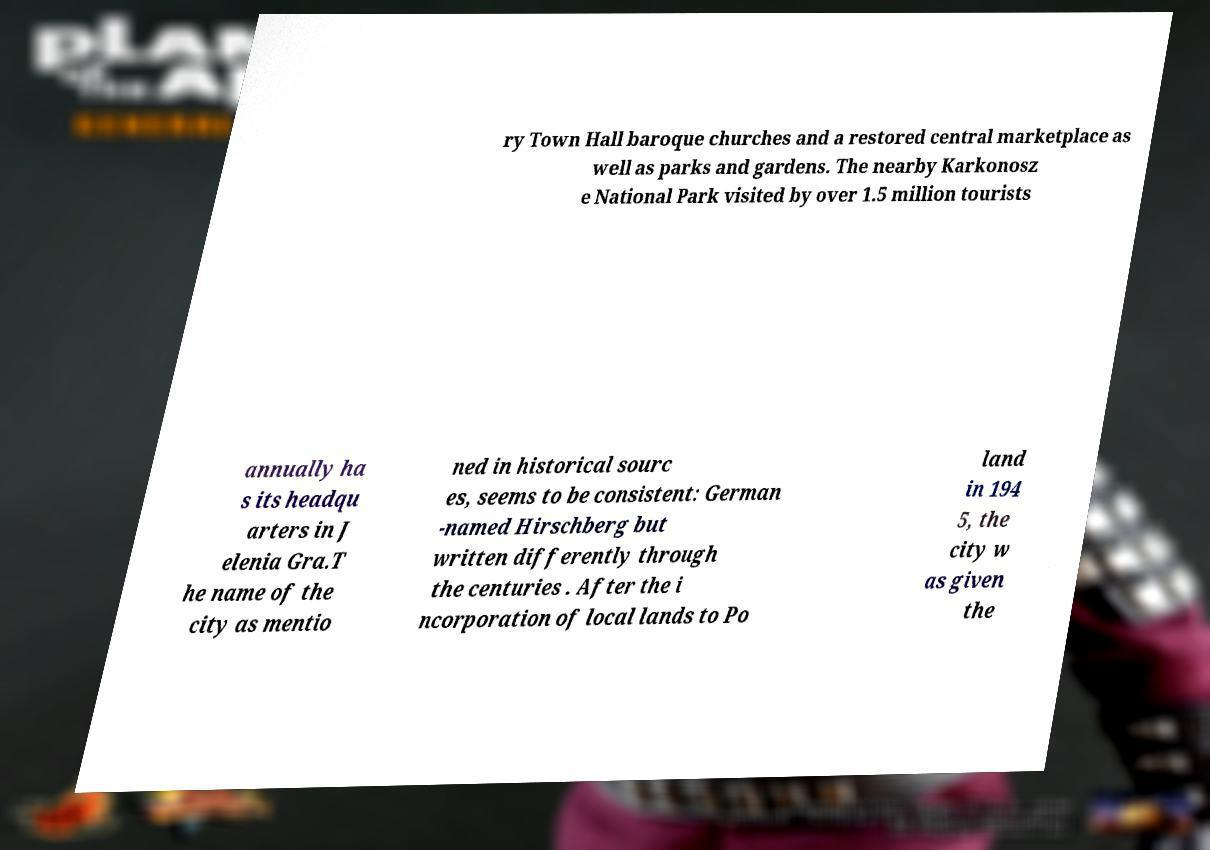There's text embedded in this image that I need extracted. Can you transcribe it verbatim? ry Town Hall baroque churches and a restored central marketplace as well as parks and gardens. The nearby Karkonosz e National Park visited by over 1.5 million tourists annually ha s its headqu arters in J elenia Gra.T he name of the city as mentio ned in historical sourc es, seems to be consistent: German -named Hirschberg but written differently through the centuries . After the i ncorporation of local lands to Po land in 194 5, the city w as given the 